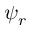Convert formula to latex. <formula><loc_0><loc_0><loc_500><loc_500>\psi _ { r }</formula> 